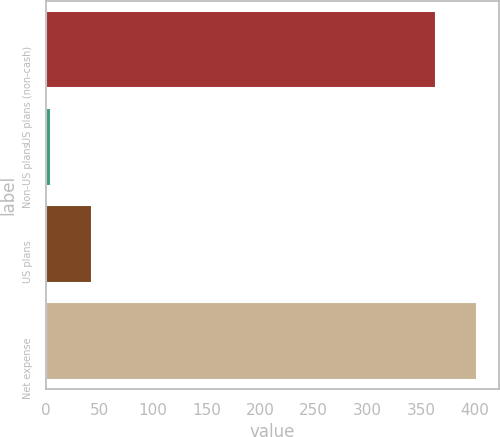Convert chart to OTSL. <chart><loc_0><loc_0><loc_500><loc_500><bar_chart><fcel>US plans (non-cash)<fcel>Non-US plans<fcel>US plans<fcel>Net expense<nl><fcel>364<fcel>5<fcel>43.3<fcel>402.3<nl></chart> 